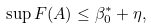Convert formula to latex. <formula><loc_0><loc_0><loc_500><loc_500>\sup F ( A ) \leq \beta ^ { \ast } _ { 0 } + \eta ,</formula> 